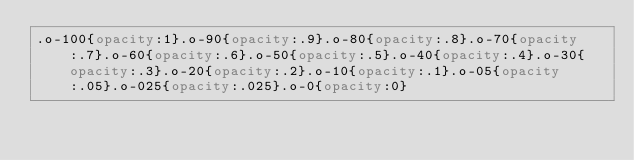<code> <loc_0><loc_0><loc_500><loc_500><_CSS_>.o-100{opacity:1}.o-90{opacity:.9}.o-80{opacity:.8}.o-70{opacity:.7}.o-60{opacity:.6}.o-50{opacity:.5}.o-40{opacity:.4}.o-30{opacity:.3}.o-20{opacity:.2}.o-10{opacity:.1}.o-05{opacity:.05}.o-025{opacity:.025}.o-0{opacity:0}

</code> 